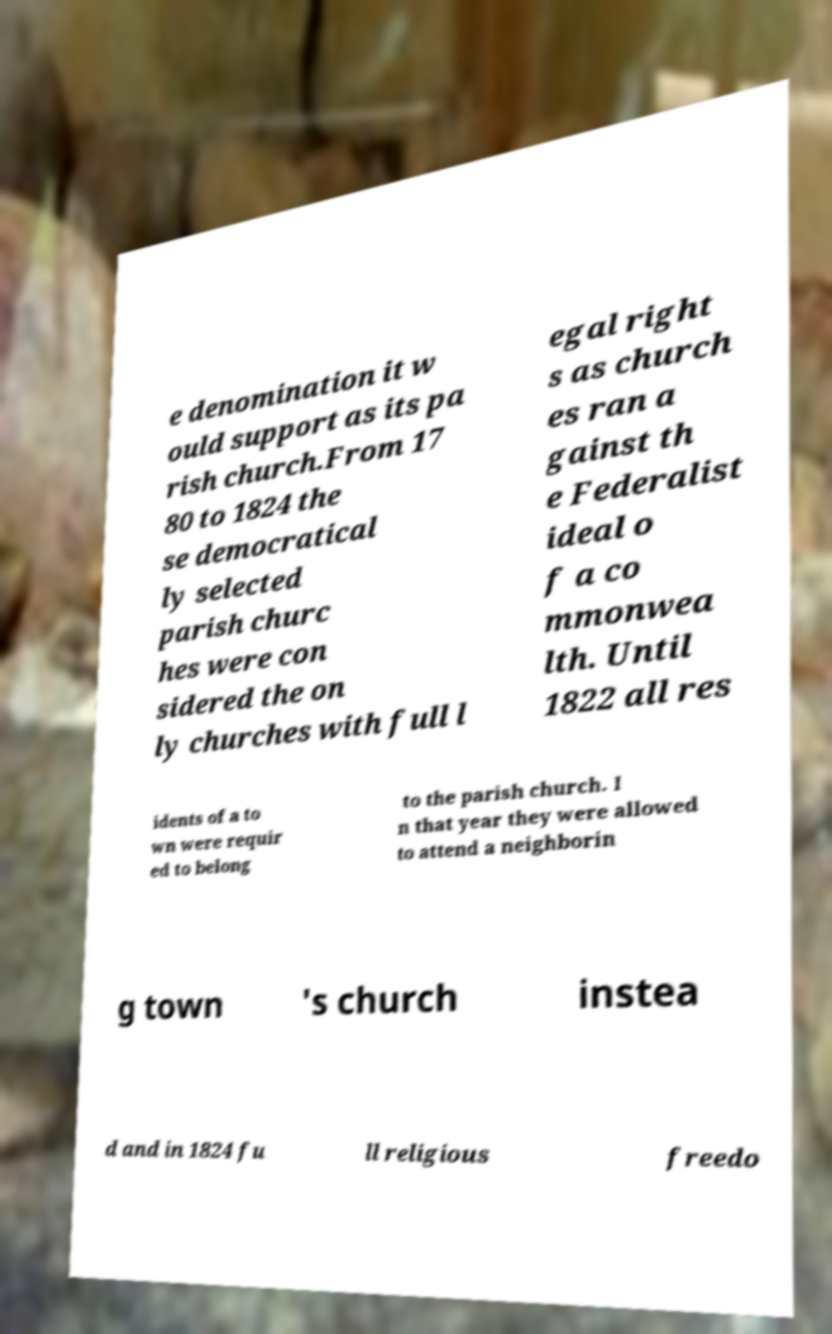For documentation purposes, I need the text within this image transcribed. Could you provide that? e denomination it w ould support as its pa rish church.From 17 80 to 1824 the se democratical ly selected parish churc hes were con sidered the on ly churches with full l egal right s as church es ran a gainst th e Federalist ideal o f a co mmonwea lth. Until 1822 all res idents of a to wn were requir ed to belong to the parish church. I n that year they were allowed to attend a neighborin g town 's church instea d and in 1824 fu ll religious freedo 